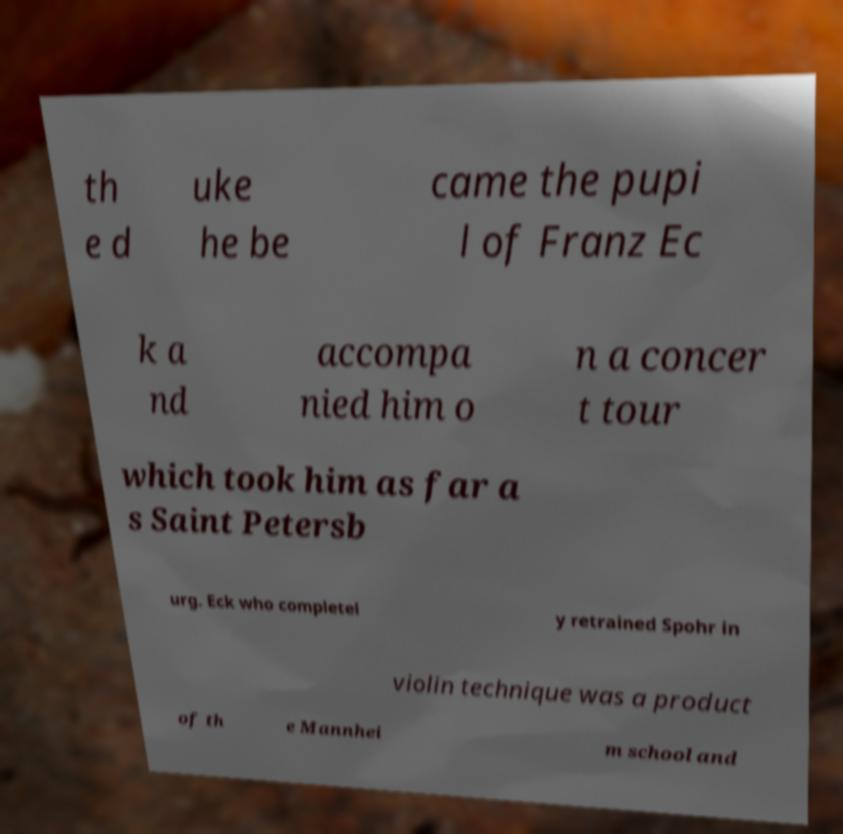Can you accurately transcribe the text from the provided image for me? th e d uke he be came the pupi l of Franz Ec k a nd accompa nied him o n a concer t tour which took him as far a s Saint Petersb urg. Eck who completel y retrained Spohr in violin technique was a product of th e Mannhei m school and 